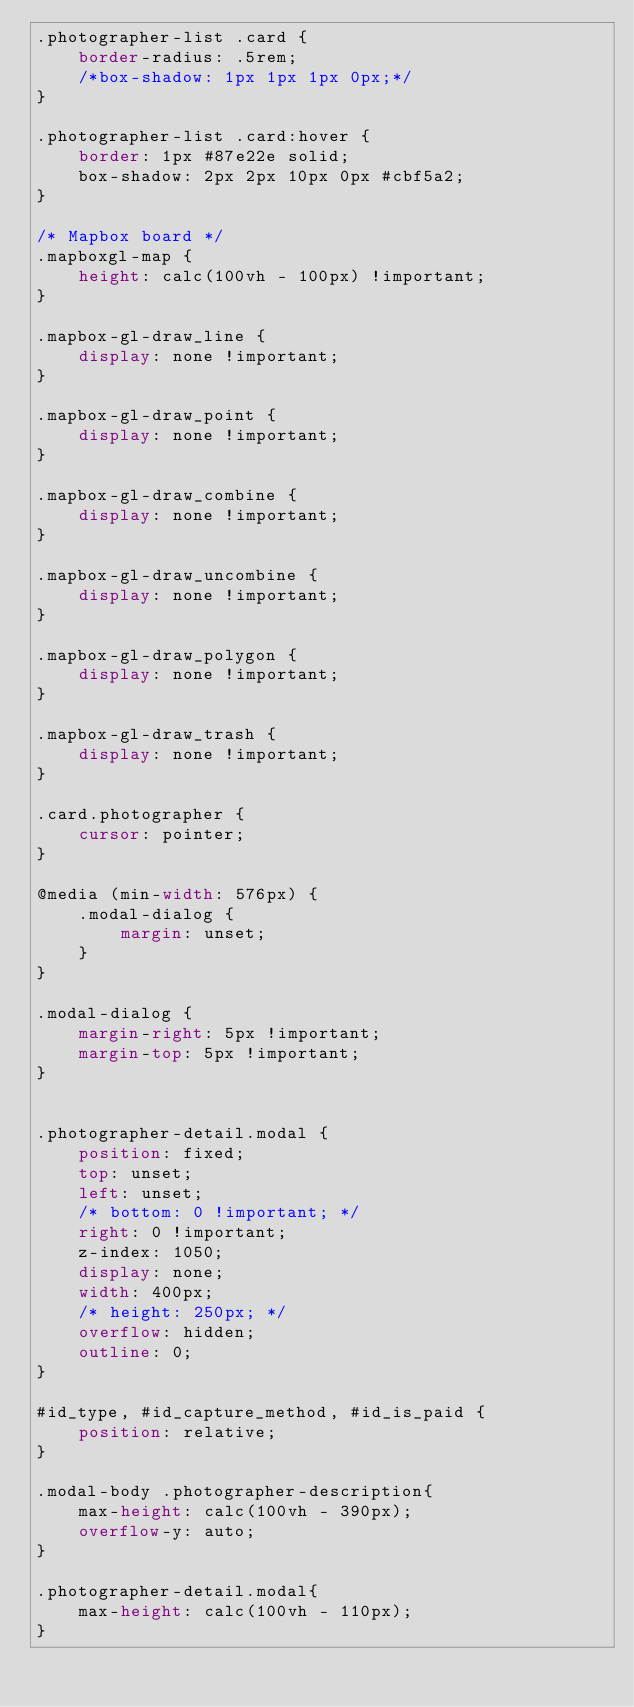<code> <loc_0><loc_0><loc_500><loc_500><_CSS_>.photographer-list .card {
    border-radius: .5rem;
    /*box-shadow: 1px 1px 1px 0px;*/
}

.photographer-list .card:hover {
    border: 1px #87e22e solid;
    box-shadow: 2px 2px 10px 0px #cbf5a2;
}

/* Mapbox board */
.mapboxgl-map {
    height: calc(100vh - 100px) !important;
}

.mapbox-gl-draw_line {
    display: none !important;
}

.mapbox-gl-draw_point {
    display: none !important;
}

.mapbox-gl-draw_combine {
    display: none !important;
}

.mapbox-gl-draw_uncombine {
    display: none !important;
}

.mapbox-gl-draw_polygon {
    display: none !important;
}

.mapbox-gl-draw_trash {
    display: none !important;
}

.card.photographer {
    cursor: pointer;
}

@media (min-width: 576px) {
    .modal-dialog {
        margin: unset;
    }
}

.modal-dialog {
    margin-right: 5px !important;
    margin-top: 5px !important;
}


.photographer-detail.modal {
    position: fixed;
    top: unset;
    left: unset;
    /* bottom: 0 !important; */
    right: 0 !important;
    z-index: 1050;
    display: none;
    width: 400px;
    /* height: 250px; */
    overflow: hidden;
    outline: 0;
}

#id_type, #id_capture_method, #id_is_paid {
    position: relative;
}

.modal-body .photographer-description{
    max-height: calc(100vh - 390px);
    overflow-y: auto;
}

.photographer-detail.modal{
    max-height: calc(100vh - 110px);
}</code> 